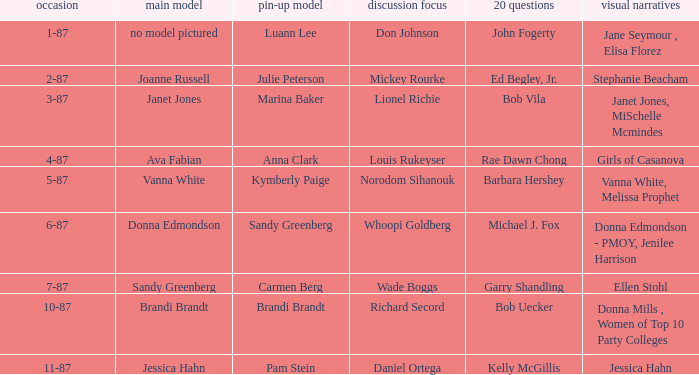When was the Kymberly Paige the Centerfold? 5-87. 